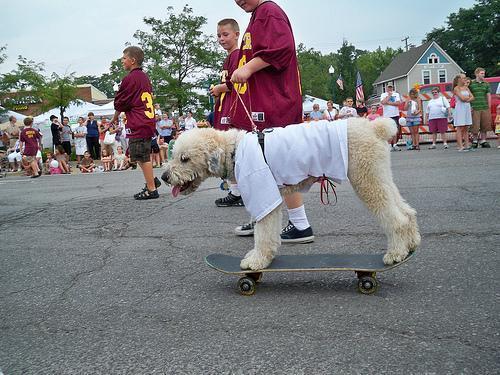How many dogs are seen?
Give a very brief answer. 1. 